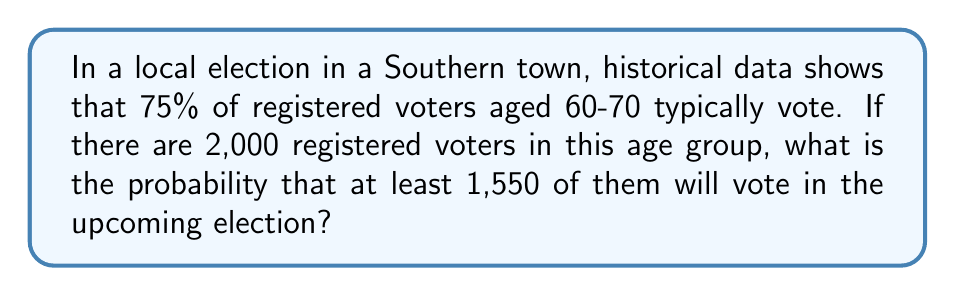Show me your answer to this math problem. Let's approach this step-by-step using the binomial distribution:

1) Let $X$ be the number of voters aged 60-70 who vote.

2) We know:
   $n = 2000$ (number of registered voters aged 60-70)
   $p = 0.75$ (probability of each voter voting)
   We want to find $P(X \geq 1550)$

3) Using the binomial distribution would be computationally intensive, so we can approximate using the normal distribution since $n$ is large and $np$ and $n(1-p)$ are both greater than 5.

4) For the normal approximation, we need the mean and standard deviation:
   $\mu = np = 2000 * 0.75 = 1500$
   $\sigma = \sqrt{np(1-p)} = \sqrt{2000 * 0.75 * 0.25} = \sqrt{375} \approx 19.36$

5) We need to find $P(X \geq 1550)$. With continuity correction:
   $P(X \geq 1550) = P(X > 1549.5)$

6) Standardizing:
   $z = \frac{1549.5 - 1500}{19.36} \approx 2.56$

7) Using a standard normal table or calculator:
   $P(Z > 2.56) \approx 0.0052$

8) Therefore, $P(X \geq 1550) \approx 0.0052$
Answer: 0.0052 